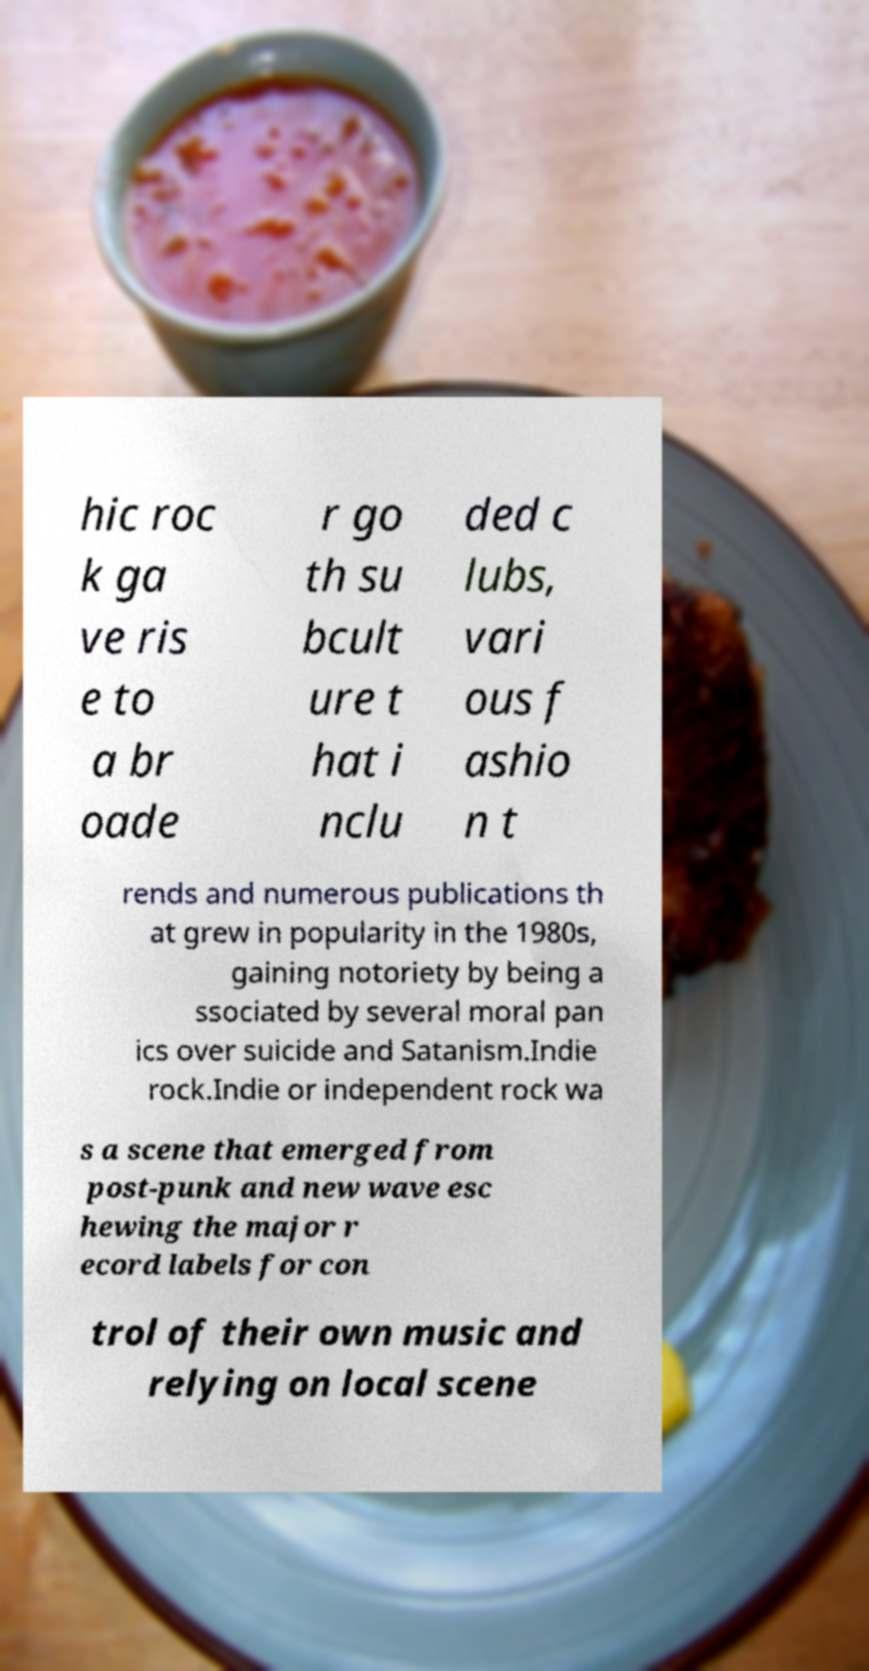Can you read and provide the text displayed in the image?This photo seems to have some interesting text. Can you extract and type it out for me? hic roc k ga ve ris e to a br oade r go th su bcult ure t hat i nclu ded c lubs, vari ous f ashio n t rends and numerous publications th at grew in popularity in the 1980s, gaining notoriety by being a ssociated by several moral pan ics over suicide and Satanism.Indie rock.Indie or independent rock wa s a scene that emerged from post-punk and new wave esc hewing the major r ecord labels for con trol of their own music and relying on local scene 